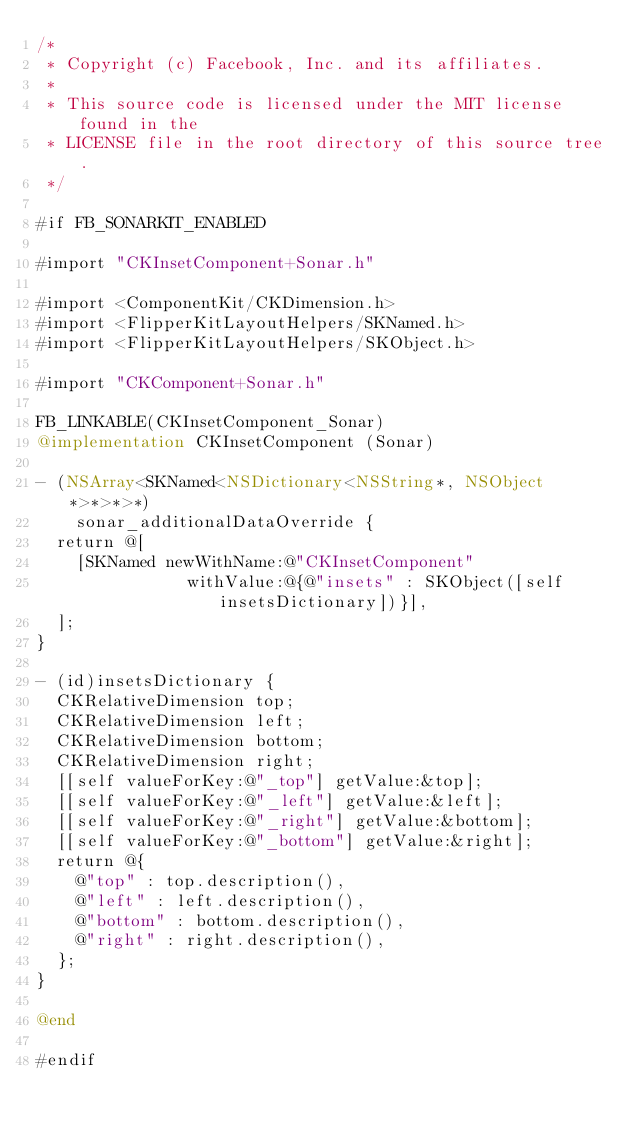Convert code to text. <code><loc_0><loc_0><loc_500><loc_500><_ObjectiveC_>/*
 * Copyright (c) Facebook, Inc. and its affiliates.
 *
 * This source code is licensed under the MIT license found in the
 * LICENSE file in the root directory of this source tree.
 */

#if FB_SONARKIT_ENABLED

#import "CKInsetComponent+Sonar.h"

#import <ComponentKit/CKDimension.h>
#import <FlipperKitLayoutHelpers/SKNamed.h>
#import <FlipperKitLayoutHelpers/SKObject.h>

#import "CKComponent+Sonar.h"

FB_LINKABLE(CKInsetComponent_Sonar)
@implementation CKInsetComponent (Sonar)

- (NSArray<SKNamed<NSDictionary<NSString*, NSObject*>*>*>*)
    sonar_additionalDataOverride {
  return @[
    [SKNamed newWithName:@"CKInsetComponent"
               withValue:@{@"insets" : SKObject([self insetsDictionary])}],
  ];
}

- (id)insetsDictionary {
  CKRelativeDimension top;
  CKRelativeDimension left;
  CKRelativeDimension bottom;
  CKRelativeDimension right;
  [[self valueForKey:@"_top"] getValue:&top];
  [[self valueForKey:@"_left"] getValue:&left];
  [[self valueForKey:@"_right"] getValue:&bottom];
  [[self valueForKey:@"_bottom"] getValue:&right];
  return @{
    @"top" : top.description(),
    @"left" : left.description(),
    @"bottom" : bottom.description(),
    @"right" : right.description(),
  };
}

@end

#endif
</code> 